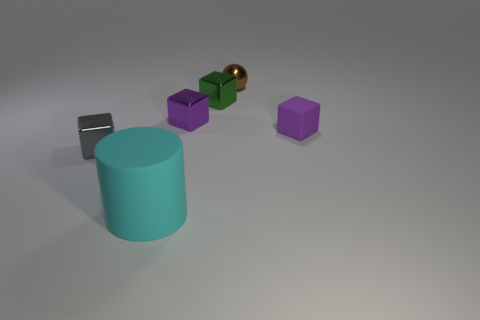Subtract all small metallic blocks. How many blocks are left? 1 Add 2 brown metal balls. How many objects exist? 8 Subtract all cylinders. How many objects are left? 5 Subtract 1 cylinders. How many cylinders are left? 0 Subtract all brown blocks. Subtract all blue spheres. How many blocks are left? 4 Subtract all cyan cubes. How many red cylinders are left? 0 Subtract all big blue matte objects. Subtract all large cyan objects. How many objects are left? 5 Add 4 tiny purple objects. How many tiny purple objects are left? 6 Add 1 large gray rubber things. How many large gray rubber things exist? 1 Subtract all gray blocks. How many blocks are left? 3 